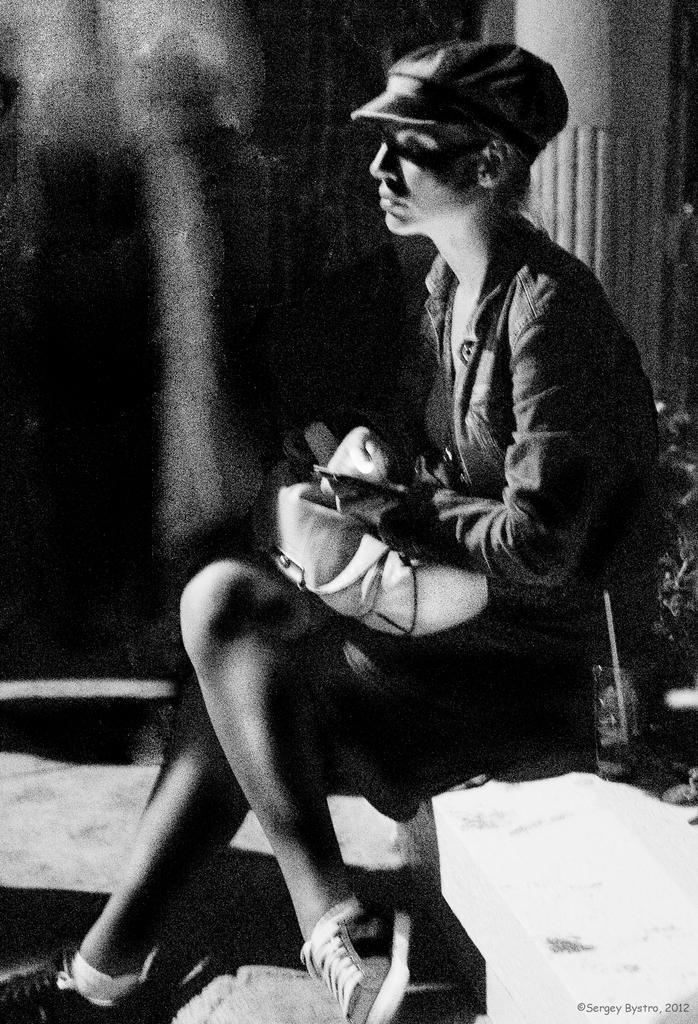How would you summarize this image in a sentence or two? In this black and white picture a person is sitting on the slab. He is having a bag on his lap. He is wearing a cap. Right side there are few plants. Behind the person there is a pillar. 